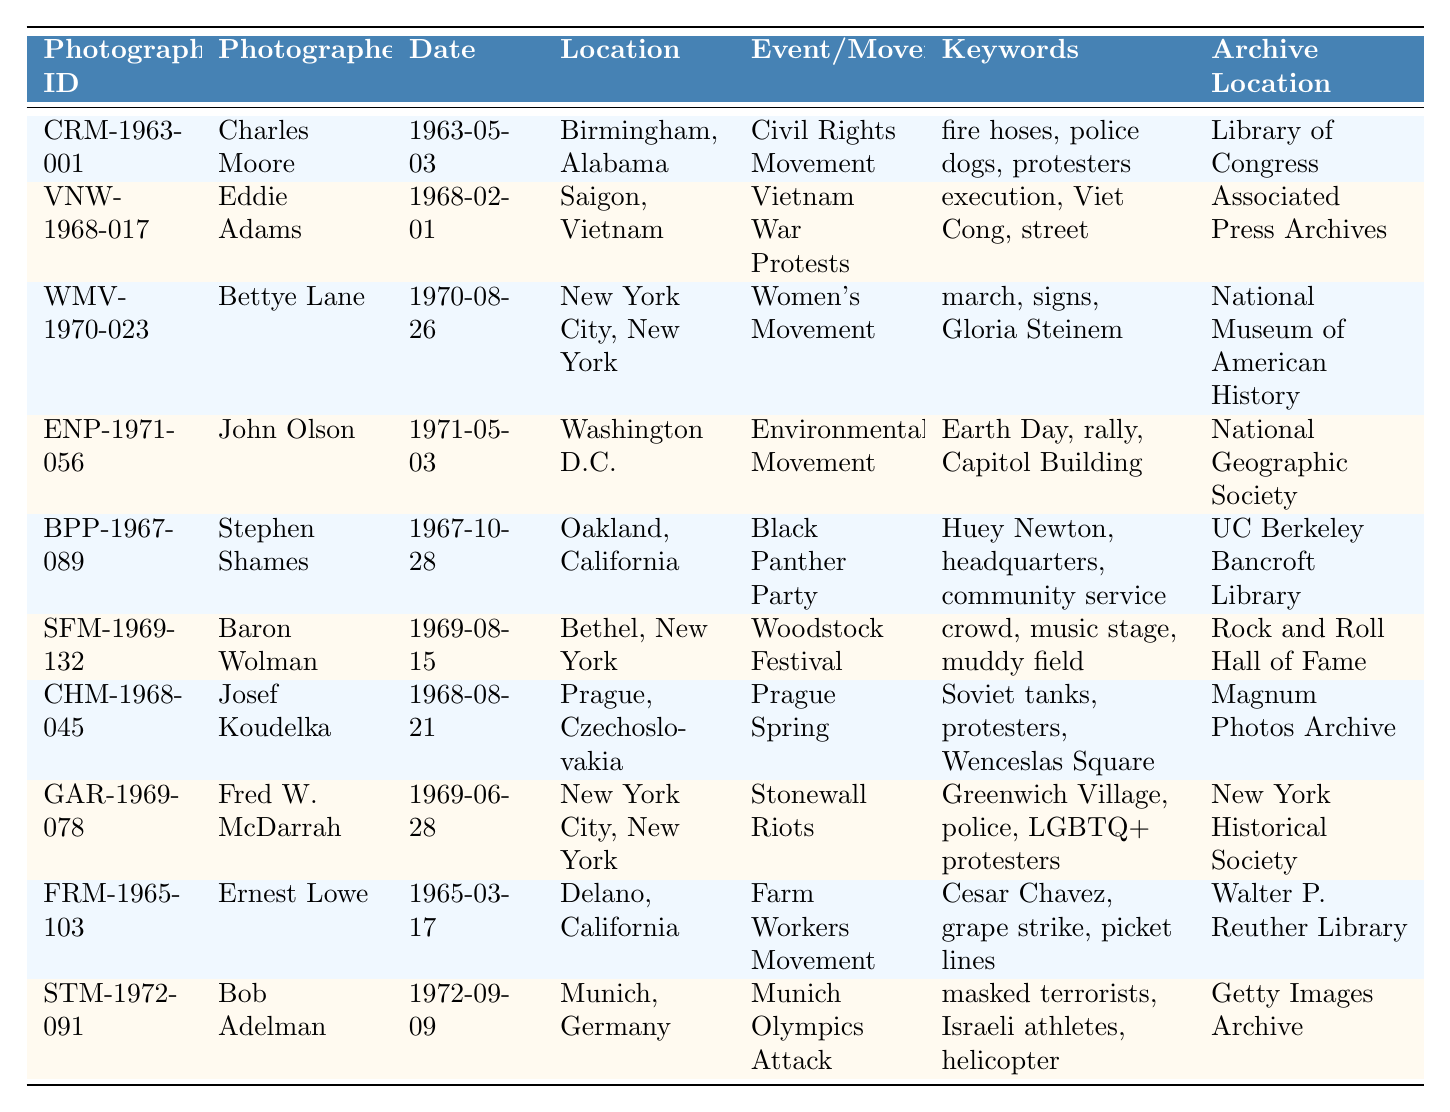What is the date of the photograph taken by Charles Moore? Looking at the row for Charles Moore, I can see the Date column shows "1963-05-03".
Answer: 1963-05-03 Which photograph documents an event in New York City? Scanning through the Location column, both "WMV-1970-023" and "GAR-1969-078" refer to events that occurred in New York City.
Answer: WMV-1970-023, GAR-1969-078 How many photographs are associated with the "Civil Rights Movement"? Only one photograph, CRM-1963-001, is listed under the "Civil Rights Movement" event in the Event/Movement column.
Answer: 1 What are the keywords associated with the Vietnam War Protests? The row for the Vietnam War Protests indicates the keywords listed are "execution, Viet Cong, street."
Answer: execution, Viet Cong, street Is there a photograph taken in Prague related to the Prague Spring? The table contains a photograph CHM-1968-045, located in Prague, and it is indeed related to the Prague Spring.
Answer: Yes Which event has the earliest date mentioned in the table? By reviewing the Date column, CRB-1963-001 shows the earliest date on "1963-05-03", indicating it corresponds to the Civil Rights Movement.
Answer: Civil Rights Movement How many photographs were taken in the year 1968? By counting the rows for 1968, I identify that there are three photographs: VNW-1968-017, CHM-1968-045, and GAR-1969-078.
Answer: 3 What is the location of the photograph associated with the Women's Movement? The Women's Movement is represented by "WMV-1970-023", which was taken in "New York City, New York".
Answer: New York City, New York Which photograph documents the Stonewall Riots? The photograph GAR-1969-078 documents the Stonewall Riots, as indicated in the Event/Movement column.
Answer: GAR-1969-078 How many different events are documented in photographs from the 1970s? By examining the table, I see that there are three distinct events from the 1970s: Women's Movement, Environmental Movement, and Munich Olympics Attack.
Answer: 3 